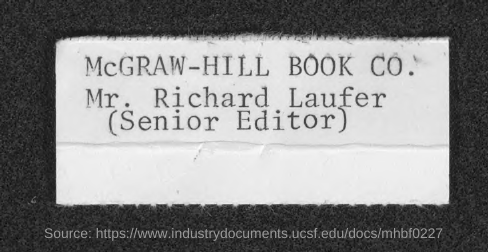Who is the Senior Editor of McGRAW-HILL BOOK CO.?
Your answer should be compact. Mr. Richard Laufer. 